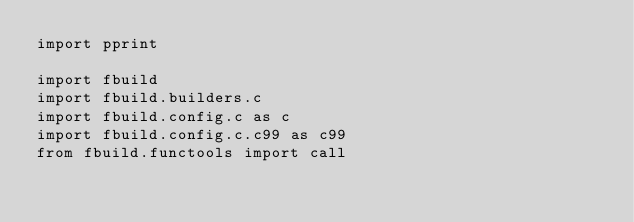<code> <loc_0><loc_0><loc_500><loc_500><_Python_>import pprint

import fbuild
import fbuild.builders.c
import fbuild.config.c as c
import fbuild.config.c.c99 as c99
from fbuild.functools import call</code> 